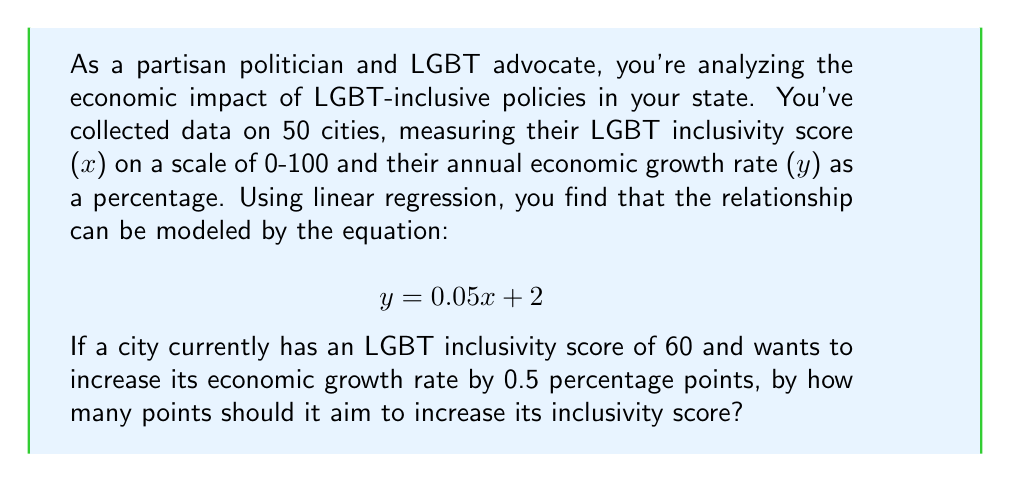Provide a solution to this math problem. To solve this problem, we'll use the given linear regression equation and follow these steps:

1. Understand the current situation:
   * Current inclusivity score (x) = 60
   * Current growth rate (y) can be calculated using the equation:
     $$ y = 0.05(60) + 2 = 3 + 2 = 5\% $$

2. Determine the target growth rate:
   * Target growth rate = Current growth rate + 0.5
   * Target growth rate = 5% + 0.5% = 5.5%

3. Use the regression equation to find the required inclusivity score:
   $$ 5.5 = 0.05x + 2 $$

4. Solve for x:
   $$ 5.5 - 2 = 0.05x $$
   $$ 3.5 = 0.05x $$
   $$ x = 3.5 / 0.05 = 70 $$

5. Calculate the required increase in inclusivity score:
   * Required increase = Target score - Current score
   * Required increase = 70 - 60 = 10 points

Therefore, the city should aim to increase its inclusivity score by 10 points to achieve the desired 0.5 percentage point increase in economic growth rate.
Answer: The city should aim to increase its LGBT inclusivity score by 10 points. 